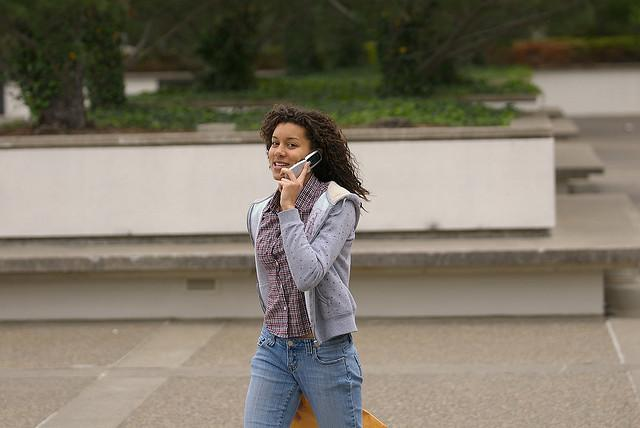How would she close the front of her sweater?

Choices:
A) zipper
B) strings
C) velcro
D) buttons zipper 